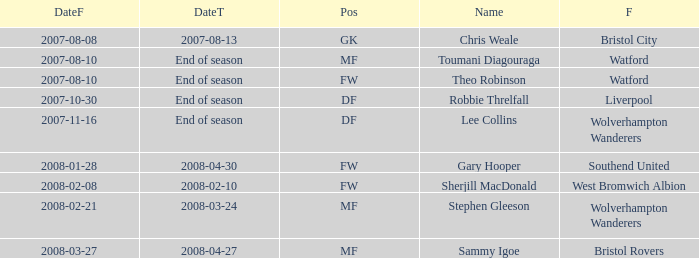Where was the player from who had the position of DF, who started 2007-10-30? Liverpool. 